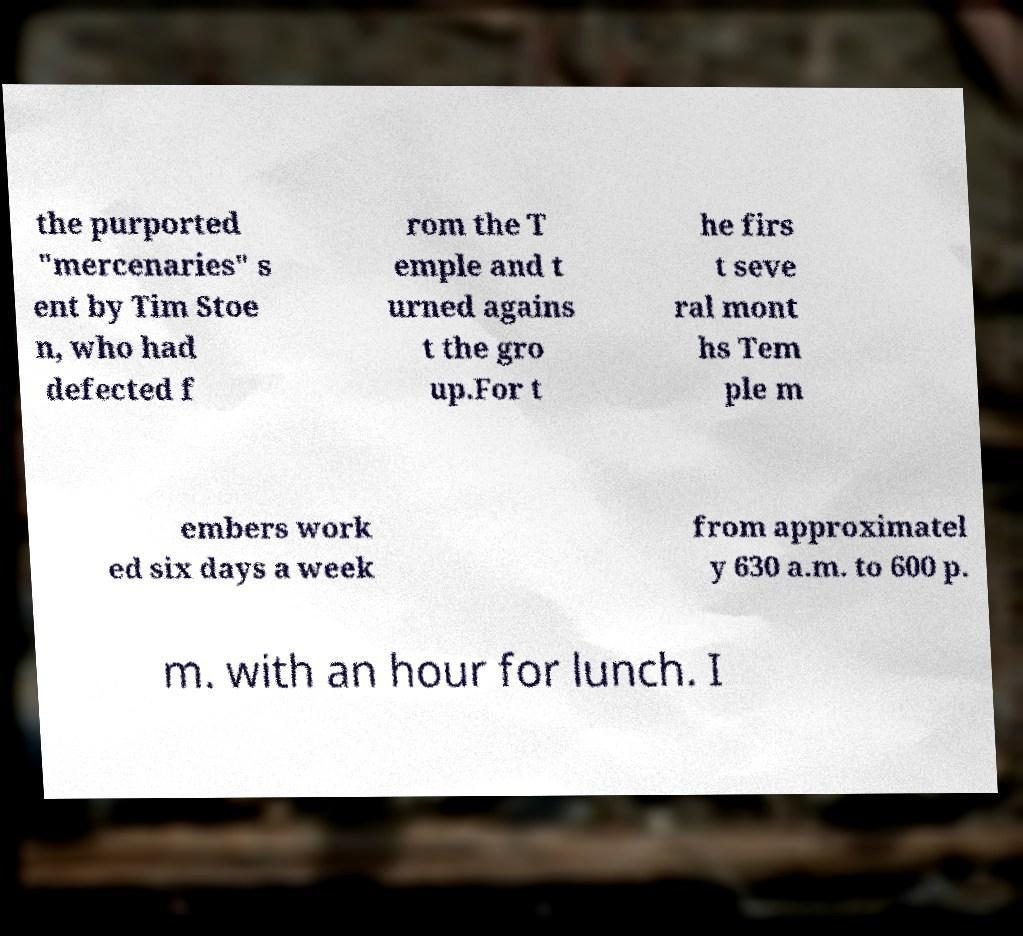What messages or text are displayed in this image? I need them in a readable, typed format. the purported "mercenaries" s ent by Tim Stoe n, who had defected f rom the T emple and t urned agains t the gro up.For t he firs t seve ral mont hs Tem ple m embers work ed six days a week from approximatel y 630 a.m. to 600 p. m. with an hour for lunch. I 